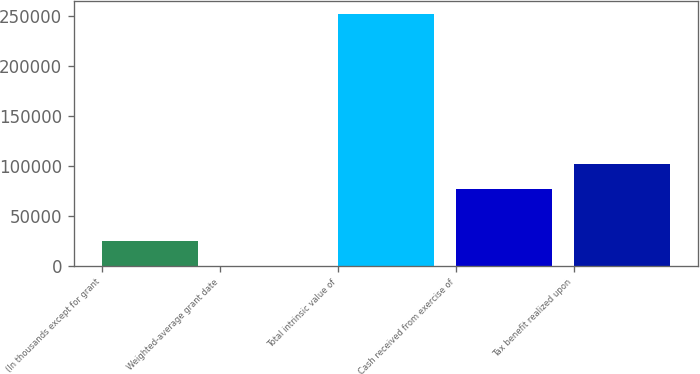Convert chart. <chart><loc_0><loc_0><loc_500><loc_500><bar_chart><fcel>(In thousands except for grant<fcel>Weighted-average grant date<fcel>Total intrinsic value of<fcel>Cash received from exercise of<fcel>Tax benefit realized upon<nl><fcel>25246.2<fcel>20.5<fcel>252277<fcel>76705<fcel>101931<nl></chart> 